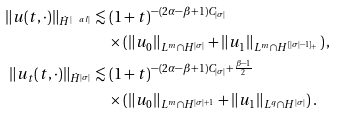<formula> <loc_0><loc_0><loc_500><loc_500>\| u ( t , \cdot ) \| _ { \dot { H } ^ { | \ a l | } } & \lesssim ( 1 + t ) ^ { - ( 2 \alpha - \beta + 1 ) C _ { | \sigma | } } \\ & \quad \times \left ( \| u _ { 0 } \| _ { L ^ { m } \cap H ^ { | \sigma | } } + \| u _ { 1 } \| _ { L ^ { m } \cap H ^ { [ | \sigma | - 1 ] _ { + } } } \right ) , \\ \| u _ { t } ( t , \cdot ) \| _ { \dot { H } ^ { | \sigma | } } & \lesssim ( 1 + t ) ^ { - ( 2 \alpha - \beta + 1 ) C _ { | \sigma | } + \frac { \beta - 1 } { 2 } } \\ & \quad \times \left ( \| u _ { 0 } \| _ { L ^ { m } \cap H ^ { | \sigma | + 1 } } + \| u _ { 1 } \| _ { L ^ { q } \cap H ^ { | \sigma | } } \right ) .</formula> 